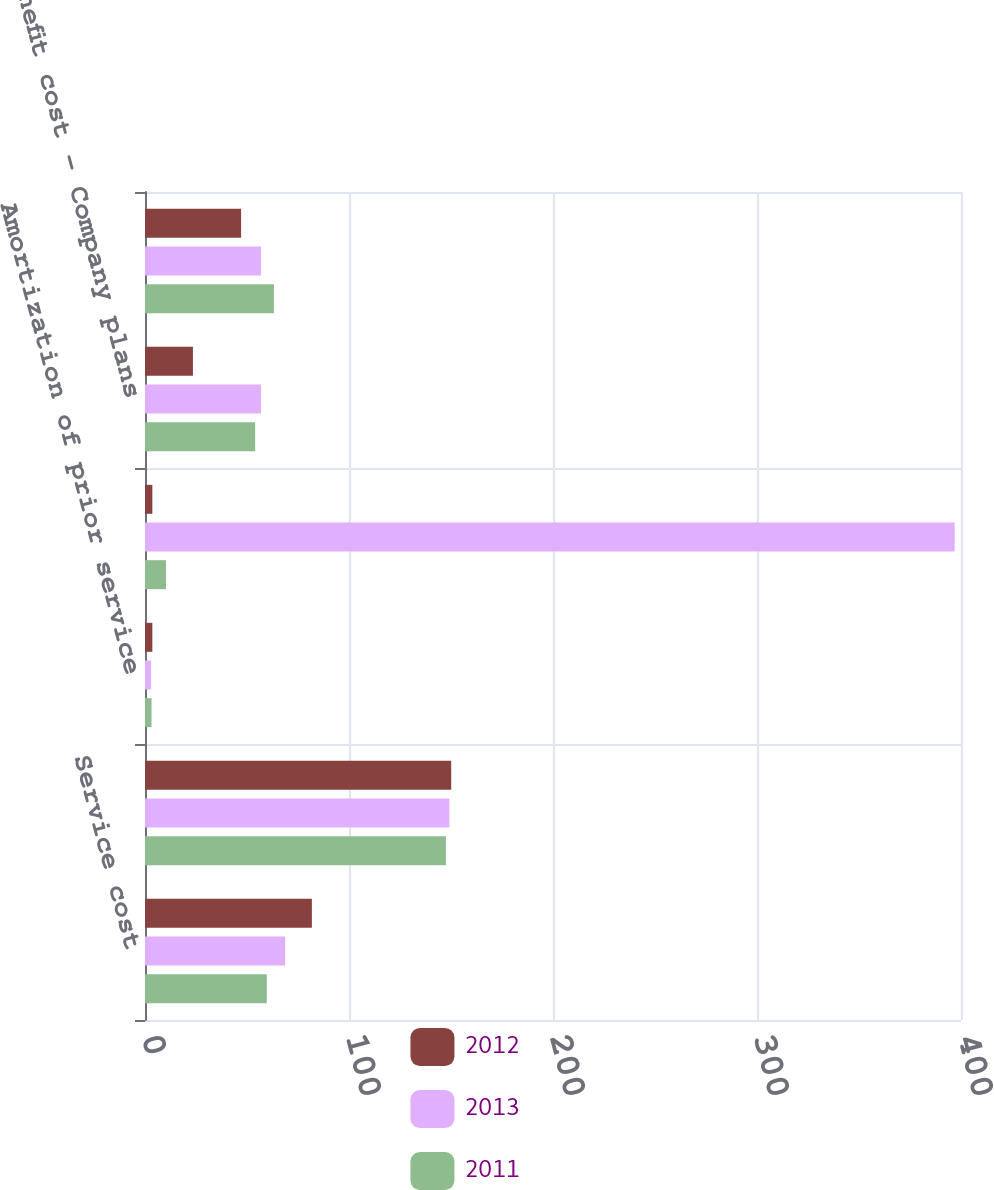<chart> <loc_0><loc_0><loc_500><loc_500><stacked_bar_chart><ecel><fcel>Service cost<fcel>Interest cost<fcel>Amortization of prior service<fcel>Recognized net actuarial loss<fcel>Benefit cost - Company plans<fcel>Total benefit cost<nl><fcel>2012<fcel>81.8<fcel>150.1<fcel>3.6<fcel>3.6<fcel>23.5<fcel>47.1<nl><fcel>2013<fcel>68.7<fcel>149.2<fcel>3<fcel>396.9<fcel>56.85<fcel>56.85<nl><fcel>2011<fcel>59.7<fcel>147.5<fcel>3.2<fcel>10.3<fcel>54<fcel>63.2<nl></chart> 